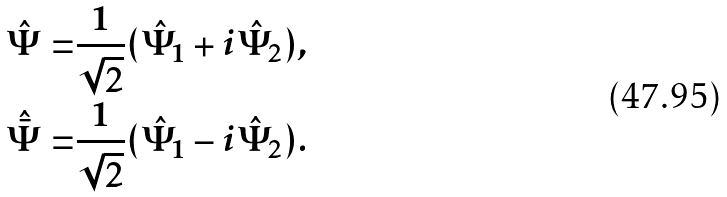Convert formula to latex. <formula><loc_0><loc_0><loc_500><loc_500>\hat { \Psi } = & \frac { 1 } { \sqrt { 2 } } ( \hat { \Psi } _ { 1 } + i \hat { \Psi } _ { 2 } ) , \\ \hat { \bar { \Psi } } = & \frac { 1 } { \sqrt { 2 } } ( \hat { \Psi } _ { 1 } - i \hat { \Psi } _ { 2 } ) .</formula> 